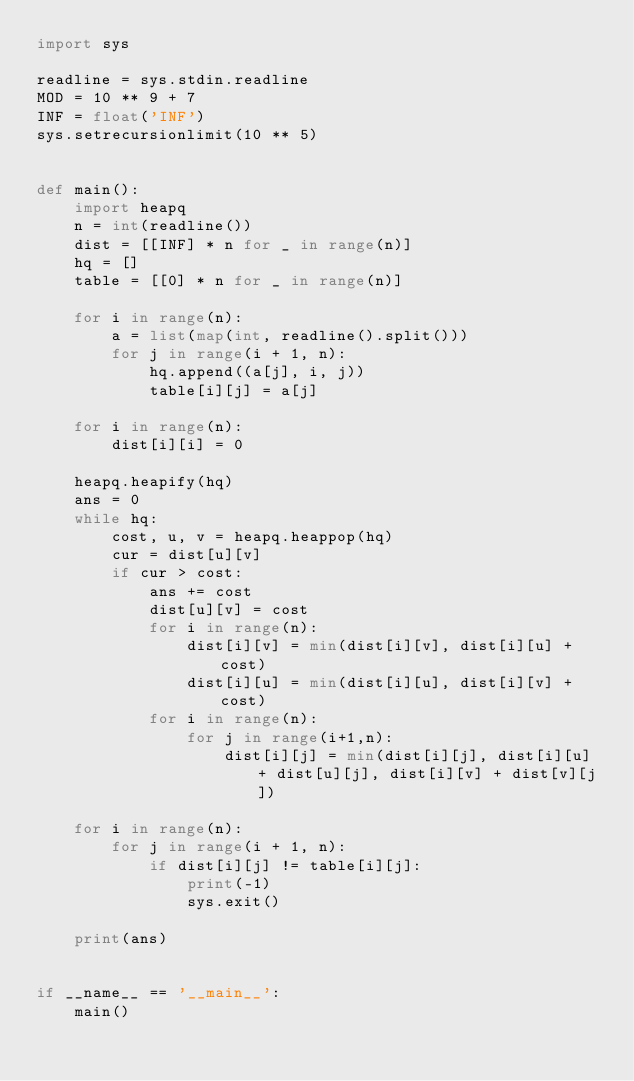<code> <loc_0><loc_0><loc_500><loc_500><_Python_>import sys

readline = sys.stdin.readline
MOD = 10 ** 9 + 7
INF = float('INF')
sys.setrecursionlimit(10 ** 5)


def main():
    import heapq
    n = int(readline())
    dist = [[INF] * n for _ in range(n)]
    hq = []
    table = [[0] * n for _ in range(n)]

    for i in range(n):
        a = list(map(int, readline().split()))
        for j in range(i + 1, n):
            hq.append((a[j], i, j))
            table[i][j] = a[j]

    for i in range(n):
        dist[i][i] = 0

    heapq.heapify(hq)
    ans = 0
    while hq:
        cost, u, v = heapq.heappop(hq)
        cur = dist[u][v]
        if cur > cost:
            ans += cost
            dist[u][v] = cost
            for i in range(n):
                dist[i][v] = min(dist[i][v], dist[i][u] + cost)
                dist[i][u] = min(dist[i][u], dist[i][v] + cost)
            for i in range(n):
                for j in range(i+1,n):
                    dist[i][j] = min(dist[i][j], dist[i][u] + dist[u][j], dist[i][v] + dist[v][j])

    for i in range(n):
        for j in range(i + 1, n):
            if dist[i][j] != table[i][j]:
                print(-1)
                sys.exit()

    print(ans)


if __name__ == '__main__':
    main()
</code> 